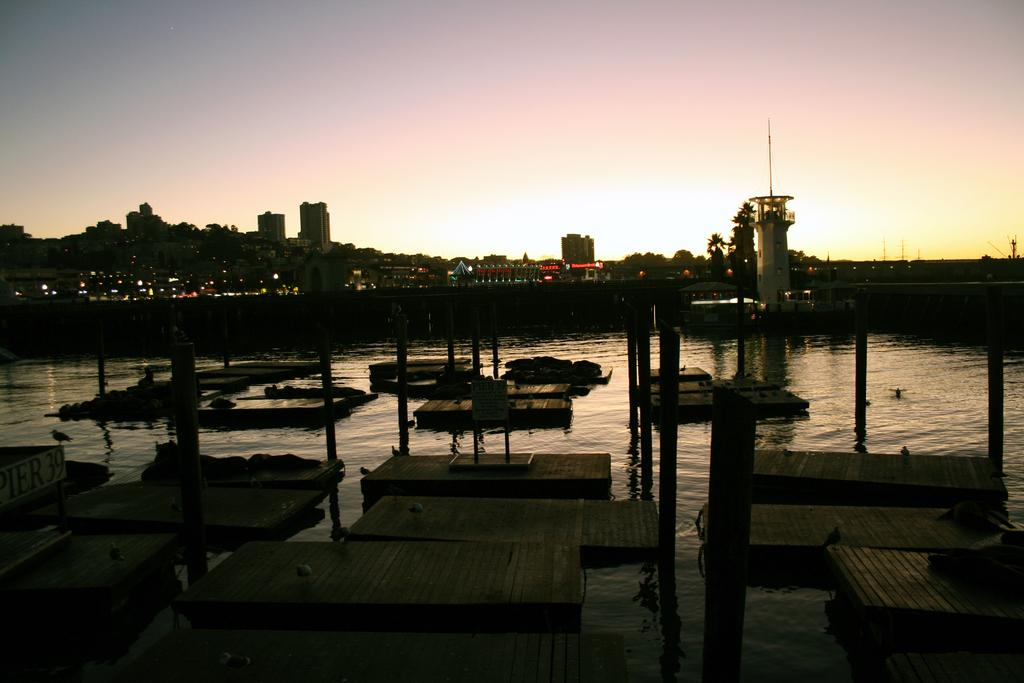What is placed on the water in the image? There are wooden boards placed on the water. What else can be seen in the image besides the wooden boards? There is a group of poles in the image. What can be seen in the background of the image? In the background, there are buildings, trees, and the sky. What song is being sung by the kitten in the image? There is no kitten present in the image, and therefore no song can be heard or sung. 